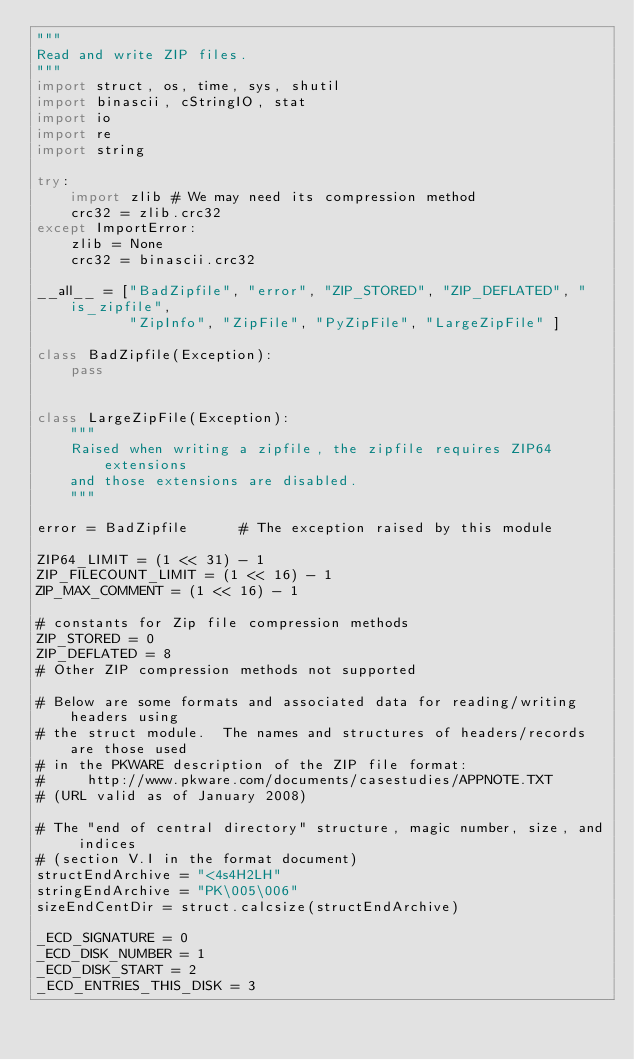Convert code to text. <code><loc_0><loc_0><loc_500><loc_500><_Python_>"""
Read and write ZIP files.
"""
import struct, os, time, sys, shutil
import binascii, cStringIO, stat
import io
import re
import string

try:
    import zlib # We may need its compression method
    crc32 = zlib.crc32
except ImportError:
    zlib = None
    crc32 = binascii.crc32

__all__ = ["BadZipfile", "error", "ZIP_STORED", "ZIP_DEFLATED", "is_zipfile",
           "ZipInfo", "ZipFile", "PyZipFile", "LargeZipFile" ]

class BadZipfile(Exception):
    pass


class LargeZipFile(Exception):
    """
    Raised when writing a zipfile, the zipfile requires ZIP64 extensions
    and those extensions are disabled.
    """

error = BadZipfile      # The exception raised by this module

ZIP64_LIMIT = (1 << 31) - 1
ZIP_FILECOUNT_LIMIT = (1 << 16) - 1
ZIP_MAX_COMMENT = (1 << 16) - 1

# constants for Zip file compression methods
ZIP_STORED = 0
ZIP_DEFLATED = 8
# Other ZIP compression methods not supported

# Below are some formats and associated data for reading/writing headers using
# the struct module.  The names and structures of headers/records are those used
# in the PKWARE description of the ZIP file format:
#     http://www.pkware.com/documents/casestudies/APPNOTE.TXT
# (URL valid as of January 2008)

# The "end of central directory" structure, magic number, size, and indices
# (section V.I in the format document)
structEndArchive = "<4s4H2LH"
stringEndArchive = "PK\005\006"
sizeEndCentDir = struct.calcsize(structEndArchive)

_ECD_SIGNATURE = 0
_ECD_DISK_NUMBER = 1
_ECD_DISK_START = 2
_ECD_ENTRIES_THIS_DISK = 3</code> 